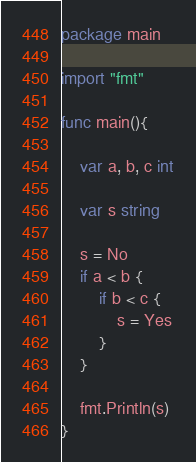<code> <loc_0><loc_0><loc_500><loc_500><_Go_>package main

import "fmt"

func main(){

    var a, b, c int

    var s string

    s = No
    if a < b {
        if b < c {
            s = Yes
        }
    }

    fmt.Println(s)
}
</code> 